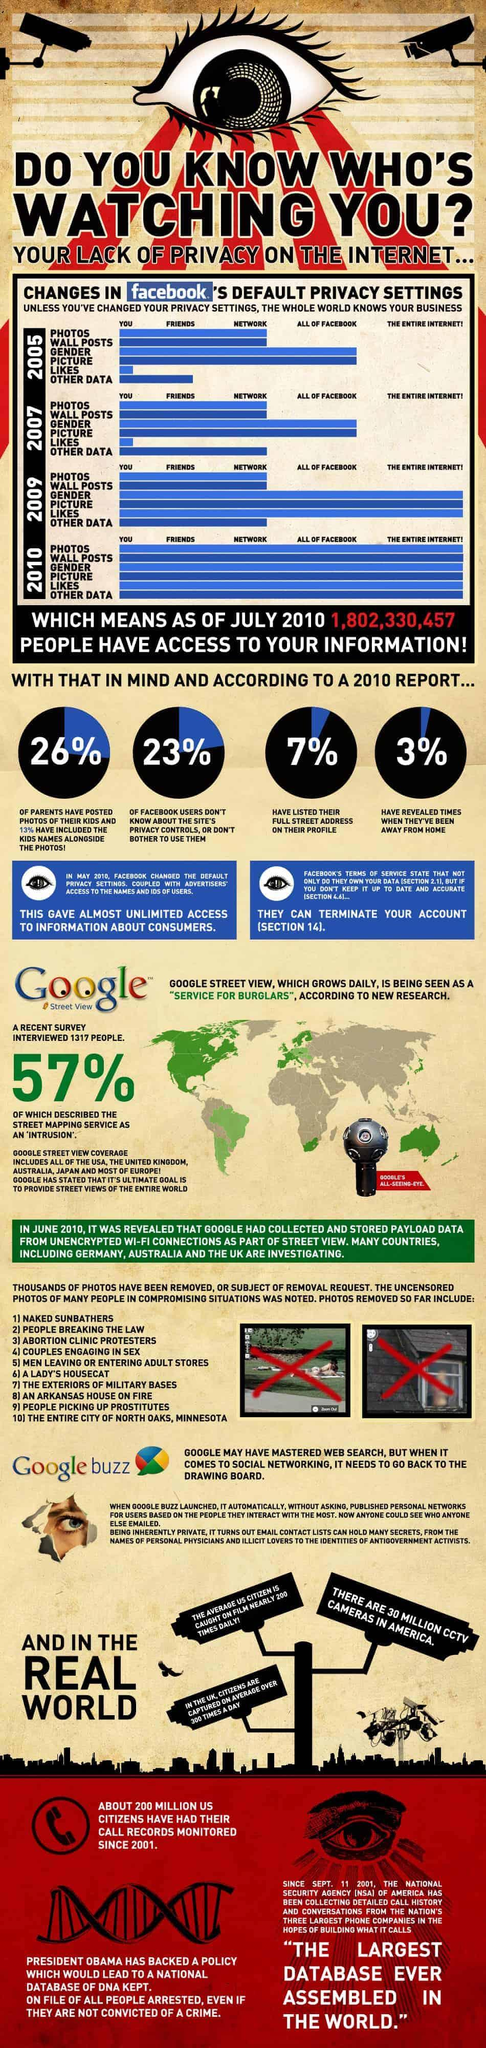List a handful of essential elements in this visual. According to the Facebook policy in 2009 and 2010, data that is accessible to the entire internet includes gender, picture, and likes. According to Facebook's policy in 2007, the gender information of a user could be viewed by all Facebook users. The third item in the list of photos that are removed from Google data collection is abortion clinic protesters. According to a 2010 report, a significant percentage of Facebook users do not list their complete address on their profile, which is 93%. According to the 2005 policy, any Facebook user's gender and profile picture are considered publicly accessible information. 